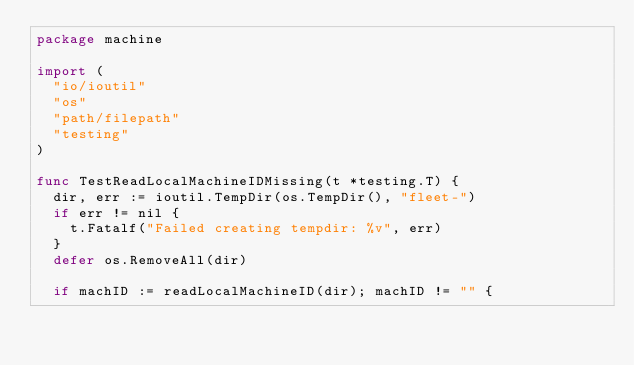<code> <loc_0><loc_0><loc_500><loc_500><_Go_>package machine

import (
	"io/ioutil"
	"os"
	"path/filepath"
	"testing"
)

func TestReadLocalMachineIDMissing(t *testing.T) {
	dir, err := ioutil.TempDir(os.TempDir(), "fleet-")
	if err != nil {
		t.Fatalf("Failed creating tempdir: %v", err)
	}
	defer os.RemoveAll(dir)

	if machID := readLocalMachineID(dir); machID != "" {</code> 